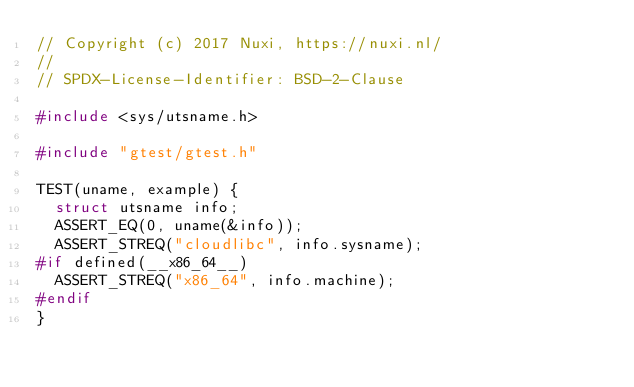<code> <loc_0><loc_0><loc_500><loc_500><_C++_>// Copyright (c) 2017 Nuxi, https://nuxi.nl/
//
// SPDX-License-Identifier: BSD-2-Clause

#include <sys/utsname.h>

#include "gtest/gtest.h"

TEST(uname, example) {
  struct utsname info;
  ASSERT_EQ(0, uname(&info));
  ASSERT_STREQ("cloudlibc", info.sysname);
#if defined(__x86_64__)
  ASSERT_STREQ("x86_64", info.machine);
#endif
}
</code> 